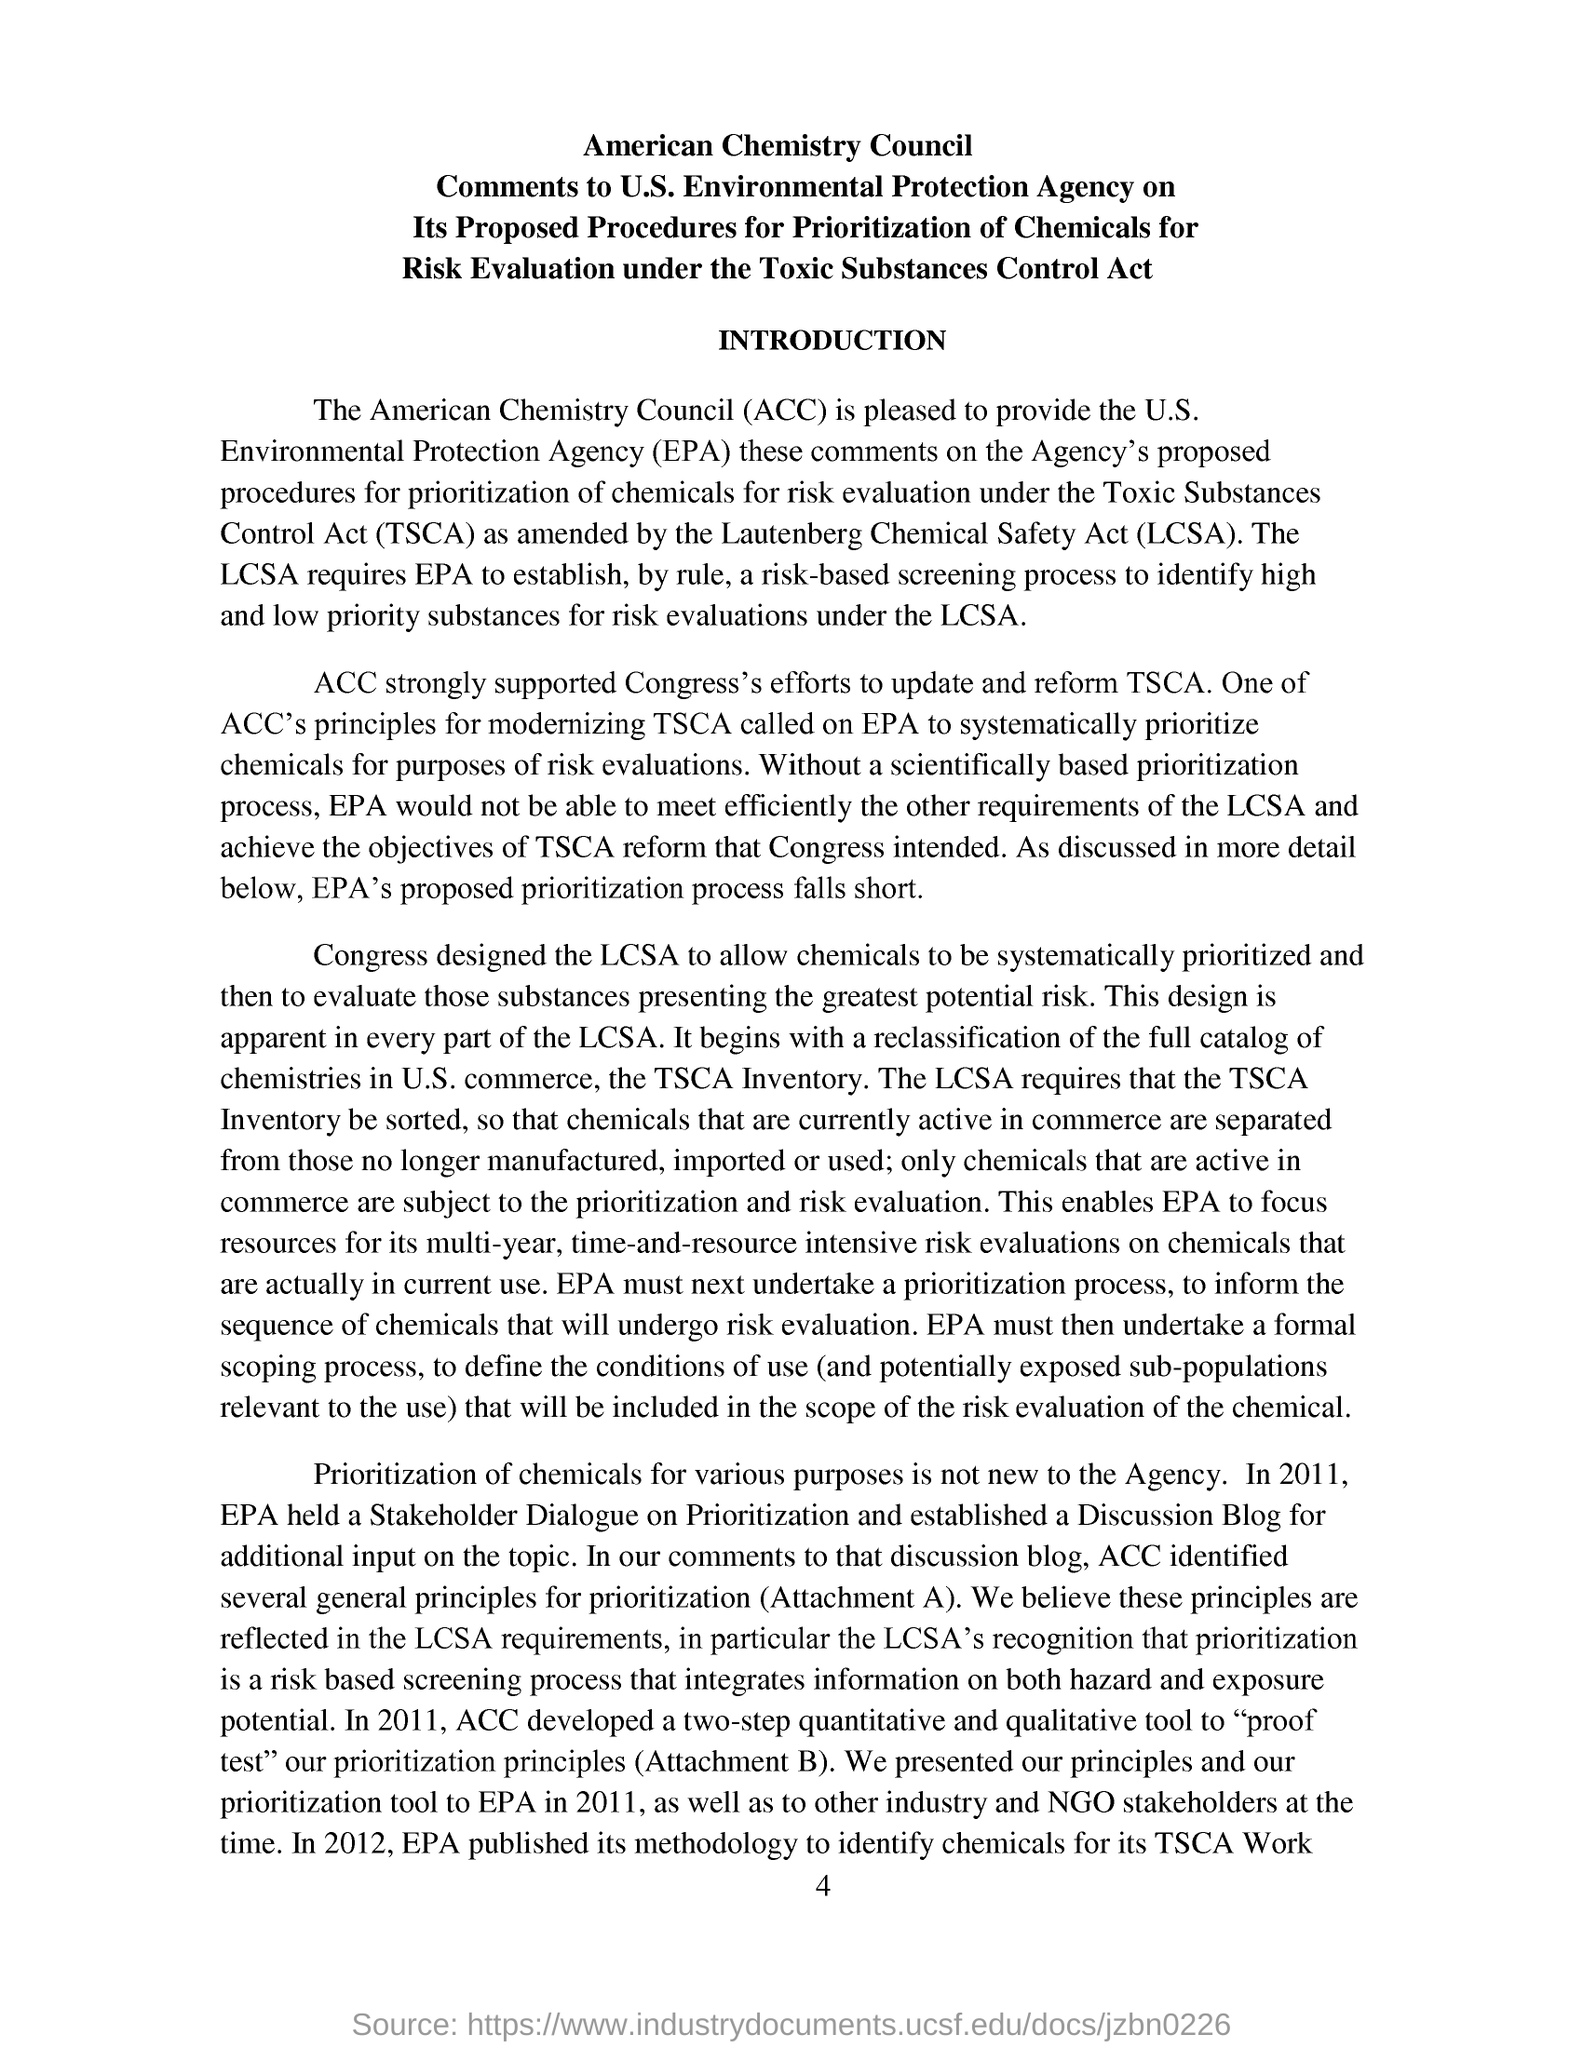Can you tell me more about the organization that provided comments to the EPA? The image shows a document from the American Chemistry Council (ACC), which is a trade association representing chemical companies in the United States. They are involved in providing expert opinions, research, and advocacy from within the industry's perspective on matters related to chemical manufacturing, including regulation such as the TSCA. What is the significant change introduced by the Lautenberg Chemical Safety Act? The Lautenberg Chemical Safety Act was signed into law in June 2016 as a major overhaul of the TSCA. It strengthens the EPA's authority to regulate chemical substances, ensuring that there is an appropriate consideration of the potential risks they might pose to public health and the environment. It allows the EPA to mandate safety reviews for chemicals already on the market, prioritize chemicals for risk evaluation, and regulate high-risk substances more stringently. 